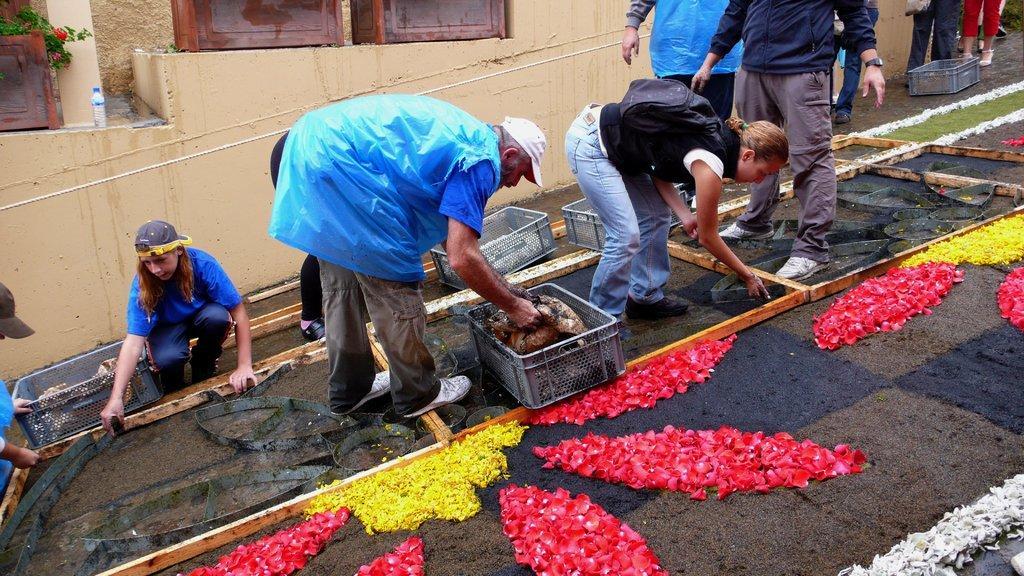Please provide a concise description of this image. In the foreground we can see the flowers on the carpet. Here we can see a few people. Here we can see the plastic baskets. Here we can see a man picking up something from the plastic basket. Here we can see a woman adjusting the metal sheet. Here we can see a bag on her back. Here we can see the bottle on the side of the wall and it is on the top left side. Here we can see the rope. 